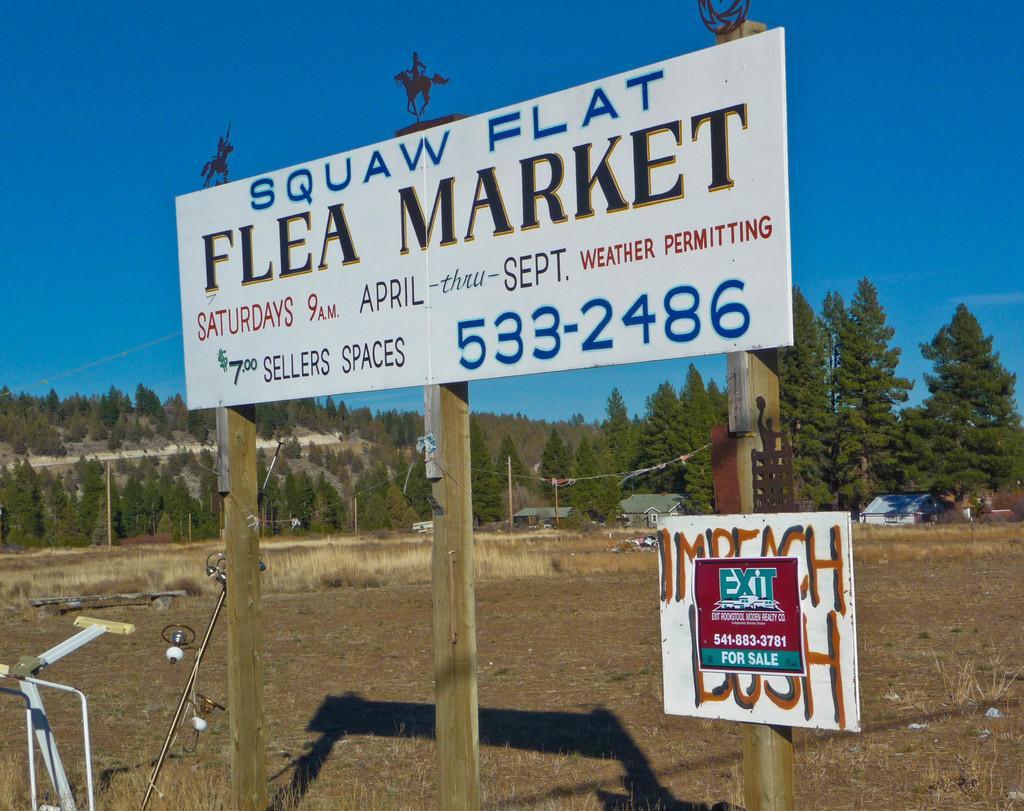Can you describe this image briefly? This is an outside view. In the foreground, I can see a white color board which is attached to three poles. On the board I can see some text. Along with this there is another small board. In the background, I can see many trees and two houses. At the top of the image I can see the sky. 